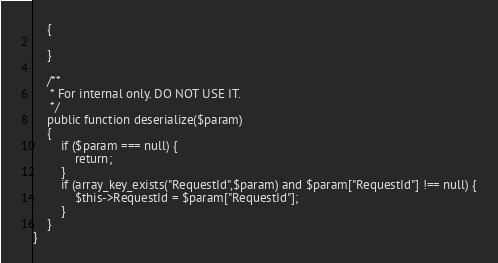<code> <loc_0><loc_0><loc_500><loc_500><_PHP_>    {

    }

    /**
     * For internal only. DO NOT USE IT.
     */
    public function deserialize($param)
    {
        if ($param === null) {
            return;
        }
        if (array_key_exists("RequestId",$param) and $param["RequestId"] !== null) {
            $this->RequestId = $param["RequestId"];
        }
    }
}
</code> 